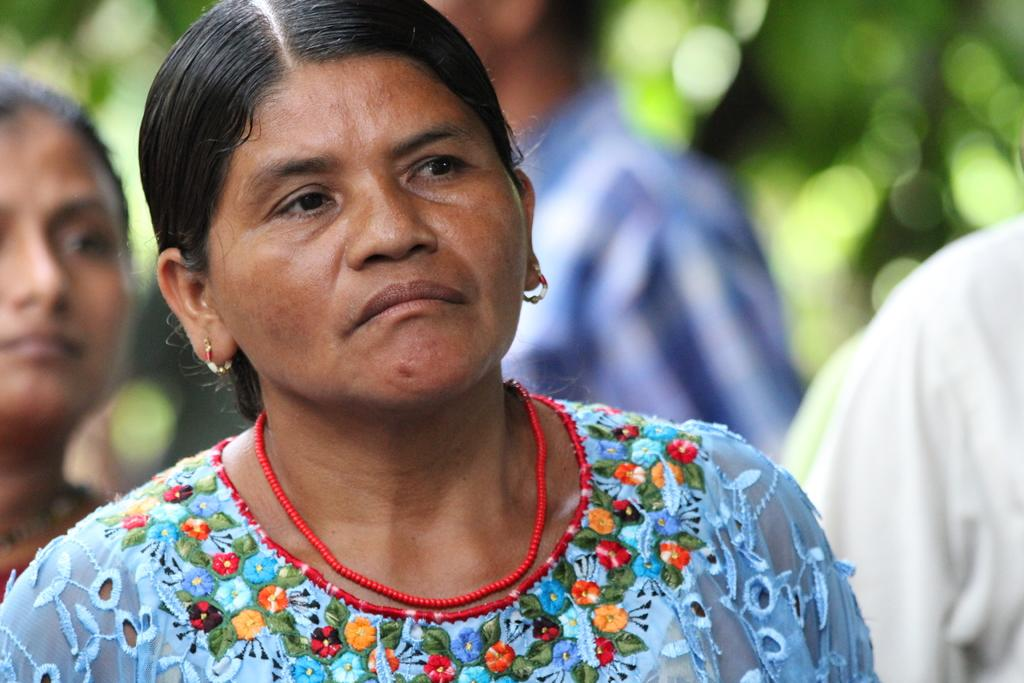What can be seen in the image? There is a group of people in the image. How are the people dressed? The people are wearing different color dresses. Can you describe the background of the image? The background of the image is blurred. What type of alarm is ringing in the image? There is no alarm present in the image. What thoughts are the people in the image having? We cannot determine the thoughts of the people in the image based on the provided facts. 